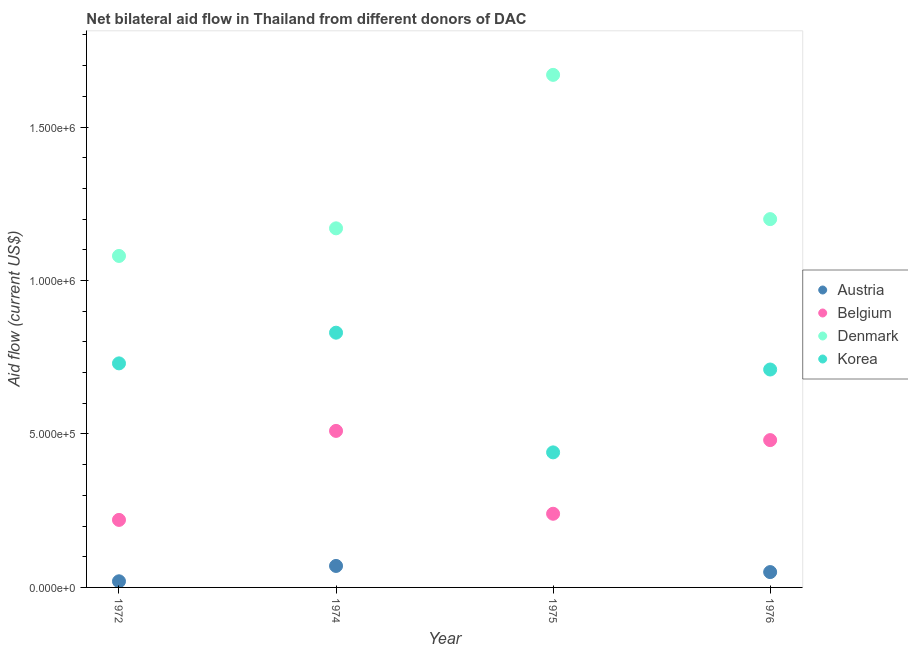What is the amount of aid given by austria in 1974?
Offer a very short reply. 7.00e+04. Across all years, what is the maximum amount of aid given by belgium?
Your response must be concise. 5.10e+05. Across all years, what is the minimum amount of aid given by korea?
Your answer should be compact. 4.40e+05. In which year was the amount of aid given by korea maximum?
Offer a very short reply. 1974. What is the total amount of aid given by belgium in the graph?
Keep it short and to the point. 1.45e+06. What is the difference between the amount of aid given by denmark in 1972 and that in 1975?
Your answer should be very brief. -5.90e+05. What is the difference between the amount of aid given by denmark in 1975 and the amount of aid given by korea in 1972?
Give a very brief answer. 9.40e+05. What is the average amount of aid given by korea per year?
Your response must be concise. 6.78e+05. In the year 1972, what is the difference between the amount of aid given by belgium and amount of aid given by denmark?
Provide a short and direct response. -8.60e+05. What is the ratio of the amount of aid given by korea in 1974 to that in 1976?
Your answer should be very brief. 1.17. Is the amount of aid given by denmark in 1972 less than that in 1974?
Give a very brief answer. Yes. Is the difference between the amount of aid given by korea in 1974 and 1975 greater than the difference between the amount of aid given by belgium in 1974 and 1975?
Keep it short and to the point. Yes. What is the difference between the highest and the lowest amount of aid given by korea?
Provide a short and direct response. 3.90e+05. In how many years, is the amount of aid given by austria greater than the average amount of aid given by austria taken over all years?
Your response must be concise. 2. Is the sum of the amount of aid given by denmark in 1975 and 1976 greater than the maximum amount of aid given by belgium across all years?
Provide a short and direct response. Yes. How many dotlines are there?
Provide a succinct answer. 4. How many years are there in the graph?
Offer a very short reply. 4. Are the values on the major ticks of Y-axis written in scientific E-notation?
Keep it short and to the point. Yes. How are the legend labels stacked?
Keep it short and to the point. Vertical. What is the title of the graph?
Provide a short and direct response. Net bilateral aid flow in Thailand from different donors of DAC. What is the label or title of the Y-axis?
Your answer should be compact. Aid flow (current US$). What is the Aid flow (current US$) in Belgium in 1972?
Give a very brief answer. 2.20e+05. What is the Aid flow (current US$) of Denmark in 1972?
Give a very brief answer. 1.08e+06. What is the Aid flow (current US$) in Korea in 1972?
Provide a succinct answer. 7.30e+05. What is the Aid flow (current US$) in Belgium in 1974?
Your answer should be compact. 5.10e+05. What is the Aid flow (current US$) of Denmark in 1974?
Keep it short and to the point. 1.17e+06. What is the Aid flow (current US$) in Korea in 1974?
Offer a terse response. 8.30e+05. What is the Aid flow (current US$) in Belgium in 1975?
Your response must be concise. 2.40e+05. What is the Aid flow (current US$) in Denmark in 1975?
Your response must be concise. 1.67e+06. What is the Aid flow (current US$) of Austria in 1976?
Make the answer very short. 5.00e+04. What is the Aid flow (current US$) in Belgium in 1976?
Offer a very short reply. 4.80e+05. What is the Aid flow (current US$) in Denmark in 1976?
Offer a terse response. 1.20e+06. What is the Aid flow (current US$) in Korea in 1976?
Provide a succinct answer. 7.10e+05. Across all years, what is the maximum Aid flow (current US$) of Austria?
Ensure brevity in your answer.  7.00e+04. Across all years, what is the maximum Aid flow (current US$) in Belgium?
Your response must be concise. 5.10e+05. Across all years, what is the maximum Aid flow (current US$) in Denmark?
Ensure brevity in your answer.  1.67e+06. Across all years, what is the maximum Aid flow (current US$) in Korea?
Ensure brevity in your answer.  8.30e+05. Across all years, what is the minimum Aid flow (current US$) of Belgium?
Your response must be concise. 2.20e+05. Across all years, what is the minimum Aid flow (current US$) of Denmark?
Your response must be concise. 1.08e+06. What is the total Aid flow (current US$) of Belgium in the graph?
Your response must be concise. 1.45e+06. What is the total Aid flow (current US$) of Denmark in the graph?
Make the answer very short. 5.12e+06. What is the total Aid flow (current US$) of Korea in the graph?
Give a very brief answer. 2.71e+06. What is the difference between the Aid flow (current US$) in Austria in 1972 and that in 1974?
Keep it short and to the point. -5.00e+04. What is the difference between the Aid flow (current US$) of Belgium in 1972 and that in 1974?
Your response must be concise. -2.90e+05. What is the difference between the Aid flow (current US$) of Belgium in 1972 and that in 1975?
Your response must be concise. -2.00e+04. What is the difference between the Aid flow (current US$) of Denmark in 1972 and that in 1975?
Provide a short and direct response. -5.90e+05. What is the difference between the Aid flow (current US$) of Austria in 1972 and that in 1976?
Your answer should be compact. -3.00e+04. What is the difference between the Aid flow (current US$) in Belgium in 1972 and that in 1976?
Give a very brief answer. -2.60e+05. What is the difference between the Aid flow (current US$) in Denmark in 1974 and that in 1975?
Make the answer very short. -5.00e+05. What is the difference between the Aid flow (current US$) of Belgium in 1974 and that in 1976?
Offer a terse response. 3.00e+04. What is the difference between the Aid flow (current US$) of Korea in 1974 and that in 1976?
Your answer should be compact. 1.20e+05. What is the difference between the Aid flow (current US$) in Denmark in 1975 and that in 1976?
Provide a succinct answer. 4.70e+05. What is the difference between the Aid flow (current US$) in Austria in 1972 and the Aid flow (current US$) in Belgium in 1974?
Offer a very short reply. -4.90e+05. What is the difference between the Aid flow (current US$) in Austria in 1972 and the Aid flow (current US$) in Denmark in 1974?
Keep it short and to the point. -1.15e+06. What is the difference between the Aid flow (current US$) of Austria in 1972 and the Aid flow (current US$) of Korea in 1974?
Ensure brevity in your answer.  -8.10e+05. What is the difference between the Aid flow (current US$) of Belgium in 1972 and the Aid flow (current US$) of Denmark in 1974?
Provide a short and direct response. -9.50e+05. What is the difference between the Aid flow (current US$) of Belgium in 1972 and the Aid flow (current US$) of Korea in 1974?
Provide a succinct answer. -6.10e+05. What is the difference between the Aid flow (current US$) of Austria in 1972 and the Aid flow (current US$) of Belgium in 1975?
Offer a terse response. -2.20e+05. What is the difference between the Aid flow (current US$) of Austria in 1972 and the Aid flow (current US$) of Denmark in 1975?
Make the answer very short. -1.65e+06. What is the difference between the Aid flow (current US$) of Austria in 1972 and the Aid flow (current US$) of Korea in 1975?
Provide a short and direct response. -4.20e+05. What is the difference between the Aid flow (current US$) in Belgium in 1972 and the Aid flow (current US$) in Denmark in 1975?
Offer a very short reply. -1.45e+06. What is the difference between the Aid flow (current US$) of Belgium in 1972 and the Aid flow (current US$) of Korea in 1975?
Offer a terse response. -2.20e+05. What is the difference between the Aid flow (current US$) of Denmark in 1972 and the Aid flow (current US$) of Korea in 1975?
Keep it short and to the point. 6.40e+05. What is the difference between the Aid flow (current US$) in Austria in 1972 and the Aid flow (current US$) in Belgium in 1976?
Ensure brevity in your answer.  -4.60e+05. What is the difference between the Aid flow (current US$) in Austria in 1972 and the Aid flow (current US$) in Denmark in 1976?
Offer a terse response. -1.18e+06. What is the difference between the Aid flow (current US$) of Austria in 1972 and the Aid flow (current US$) of Korea in 1976?
Your answer should be very brief. -6.90e+05. What is the difference between the Aid flow (current US$) of Belgium in 1972 and the Aid flow (current US$) of Denmark in 1976?
Give a very brief answer. -9.80e+05. What is the difference between the Aid flow (current US$) of Belgium in 1972 and the Aid flow (current US$) of Korea in 1976?
Offer a very short reply. -4.90e+05. What is the difference between the Aid flow (current US$) of Denmark in 1972 and the Aid flow (current US$) of Korea in 1976?
Ensure brevity in your answer.  3.70e+05. What is the difference between the Aid flow (current US$) of Austria in 1974 and the Aid flow (current US$) of Belgium in 1975?
Ensure brevity in your answer.  -1.70e+05. What is the difference between the Aid flow (current US$) of Austria in 1974 and the Aid flow (current US$) of Denmark in 1975?
Ensure brevity in your answer.  -1.60e+06. What is the difference between the Aid flow (current US$) in Austria in 1974 and the Aid flow (current US$) in Korea in 1975?
Offer a very short reply. -3.70e+05. What is the difference between the Aid flow (current US$) of Belgium in 1974 and the Aid flow (current US$) of Denmark in 1975?
Provide a short and direct response. -1.16e+06. What is the difference between the Aid flow (current US$) in Denmark in 1974 and the Aid flow (current US$) in Korea in 1975?
Your answer should be compact. 7.30e+05. What is the difference between the Aid flow (current US$) of Austria in 1974 and the Aid flow (current US$) of Belgium in 1976?
Your answer should be very brief. -4.10e+05. What is the difference between the Aid flow (current US$) of Austria in 1974 and the Aid flow (current US$) of Denmark in 1976?
Give a very brief answer. -1.13e+06. What is the difference between the Aid flow (current US$) in Austria in 1974 and the Aid flow (current US$) in Korea in 1976?
Make the answer very short. -6.40e+05. What is the difference between the Aid flow (current US$) of Belgium in 1974 and the Aid flow (current US$) of Denmark in 1976?
Provide a succinct answer. -6.90e+05. What is the difference between the Aid flow (current US$) in Belgium in 1974 and the Aid flow (current US$) in Korea in 1976?
Ensure brevity in your answer.  -2.00e+05. What is the difference between the Aid flow (current US$) of Denmark in 1974 and the Aid flow (current US$) of Korea in 1976?
Your answer should be very brief. 4.60e+05. What is the difference between the Aid flow (current US$) of Belgium in 1975 and the Aid flow (current US$) of Denmark in 1976?
Provide a short and direct response. -9.60e+05. What is the difference between the Aid flow (current US$) of Belgium in 1975 and the Aid flow (current US$) of Korea in 1976?
Your response must be concise. -4.70e+05. What is the difference between the Aid flow (current US$) in Denmark in 1975 and the Aid flow (current US$) in Korea in 1976?
Ensure brevity in your answer.  9.60e+05. What is the average Aid flow (current US$) in Austria per year?
Your answer should be very brief. 3.50e+04. What is the average Aid flow (current US$) in Belgium per year?
Keep it short and to the point. 3.62e+05. What is the average Aid flow (current US$) in Denmark per year?
Keep it short and to the point. 1.28e+06. What is the average Aid flow (current US$) in Korea per year?
Your answer should be very brief. 6.78e+05. In the year 1972, what is the difference between the Aid flow (current US$) of Austria and Aid flow (current US$) of Denmark?
Offer a terse response. -1.06e+06. In the year 1972, what is the difference between the Aid flow (current US$) of Austria and Aid flow (current US$) of Korea?
Offer a terse response. -7.10e+05. In the year 1972, what is the difference between the Aid flow (current US$) in Belgium and Aid flow (current US$) in Denmark?
Keep it short and to the point. -8.60e+05. In the year 1972, what is the difference between the Aid flow (current US$) of Belgium and Aid flow (current US$) of Korea?
Offer a terse response. -5.10e+05. In the year 1974, what is the difference between the Aid flow (current US$) in Austria and Aid flow (current US$) in Belgium?
Make the answer very short. -4.40e+05. In the year 1974, what is the difference between the Aid flow (current US$) of Austria and Aid flow (current US$) of Denmark?
Provide a succinct answer. -1.10e+06. In the year 1974, what is the difference between the Aid flow (current US$) in Austria and Aid flow (current US$) in Korea?
Offer a very short reply. -7.60e+05. In the year 1974, what is the difference between the Aid flow (current US$) of Belgium and Aid flow (current US$) of Denmark?
Your answer should be compact. -6.60e+05. In the year 1974, what is the difference between the Aid flow (current US$) of Belgium and Aid flow (current US$) of Korea?
Offer a terse response. -3.20e+05. In the year 1974, what is the difference between the Aid flow (current US$) of Denmark and Aid flow (current US$) of Korea?
Offer a very short reply. 3.40e+05. In the year 1975, what is the difference between the Aid flow (current US$) of Belgium and Aid flow (current US$) of Denmark?
Offer a terse response. -1.43e+06. In the year 1975, what is the difference between the Aid flow (current US$) of Belgium and Aid flow (current US$) of Korea?
Keep it short and to the point. -2.00e+05. In the year 1975, what is the difference between the Aid flow (current US$) of Denmark and Aid flow (current US$) of Korea?
Your answer should be very brief. 1.23e+06. In the year 1976, what is the difference between the Aid flow (current US$) of Austria and Aid flow (current US$) of Belgium?
Provide a short and direct response. -4.30e+05. In the year 1976, what is the difference between the Aid flow (current US$) of Austria and Aid flow (current US$) of Denmark?
Ensure brevity in your answer.  -1.15e+06. In the year 1976, what is the difference between the Aid flow (current US$) of Austria and Aid flow (current US$) of Korea?
Keep it short and to the point. -6.60e+05. In the year 1976, what is the difference between the Aid flow (current US$) in Belgium and Aid flow (current US$) in Denmark?
Offer a very short reply. -7.20e+05. In the year 1976, what is the difference between the Aid flow (current US$) in Denmark and Aid flow (current US$) in Korea?
Make the answer very short. 4.90e+05. What is the ratio of the Aid flow (current US$) of Austria in 1972 to that in 1974?
Ensure brevity in your answer.  0.29. What is the ratio of the Aid flow (current US$) of Belgium in 1972 to that in 1974?
Provide a short and direct response. 0.43. What is the ratio of the Aid flow (current US$) of Korea in 1972 to that in 1974?
Your response must be concise. 0.88. What is the ratio of the Aid flow (current US$) of Belgium in 1972 to that in 1975?
Offer a very short reply. 0.92. What is the ratio of the Aid flow (current US$) in Denmark in 1972 to that in 1975?
Offer a terse response. 0.65. What is the ratio of the Aid flow (current US$) in Korea in 1972 to that in 1975?
Your answer should be very brief. 1.66. What is the ratio of the Aid flow (current US$) in Austria in 1972 to that in 1976?
Provide a short and direct response. 0.4. What is the ratio of the Aid flow (current US$) in Belgium in 1972 to that in 1976?
Provide a succinct answer. 0.46. What is the ratio of the Aid flow (current US$) of Korea in 1972 to that in 1976?
Make the answer very short. 1.03. What is the ratio of the Aid flow (current US$) in Belgium in 1974 to that in 1975?
Provide a succinct answer. 2.12. What is the ratio of the Aid flow (current US$) in Denmark in 1974 to that in 1975?
Offer a terse response. 0.7. What is the ratio of the Aid flow (current US$) of Korea in 1974 to that in 1975?
Make the answer very short. 1.89. What is the ratio of the Aid flow (current US$) in Austria in 1974 to that in 1976?
Provide a succinct answer. 1.4. What is the ratio of the Aid flow (current US$) of Denmark in 1974 to that in 1976?
Provide a succinct answer. 0.97. What is the ratio of the Aid flow (current US$) of Korea in 1974 to that in 1976?
Offer a very short reply. 1.17. What is the ratio of the Aid flow (current US$) in Belgium in 1975 to that in 1976?
Provide a succinct answer. 0.5. What is the ratio of the Aid flow (current US$) in Denmark in 1975 to that in 1976?
Provide a succinct answer. 1.39. What is the ratio of the Aid flow (current US$) of Korea in 1975 to that in 1976?
Ensure brevity in your answer.  0.62. What is the difference between the highest and the second highest Aid flow (current US$) in Austria?
Keep it short and to the point. 2.00e+04. What is the difference between the highest and the second highest Aid flow (current US$) in Belgium?
Give a very brief answer. 3.00e+04. What is the difference between the highest and the lowest Aid flow (current US$) of Belgium?
Give a very brief answer. 2.90e+05. What is the difference between the highest and the lowest Aid flow (current US$) in Denmark?
Keep it short and to the point. 5.90e+05. 